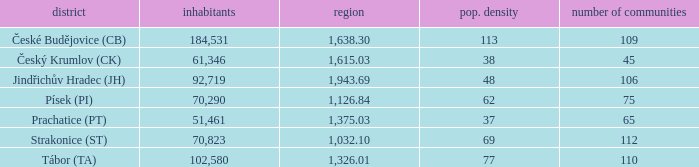How big is the area that has a population density of 113 and a population larger than 184,531? 0.0. 